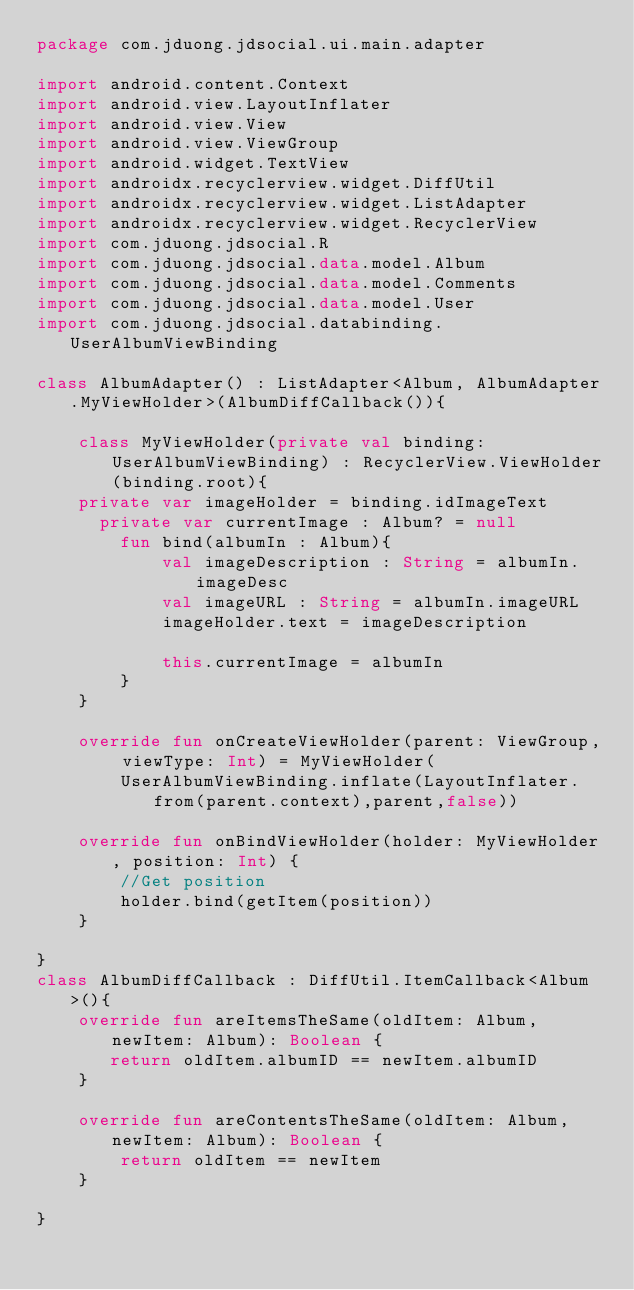<code> <loc_0><loc_0><loc_500><loc_500><_Kotlin_>package com.jduong.jdsocial.ui.main.adapter

import android.content.Context
import android.view.LayoutInflater
import android.view.View
import android.view.ViewGroup
import android.widget.TextView
import androidx.recyclerview.widget.DiffUtil
import androidx.recyclerview.widget.ListAdapter
import androidx.recyclerview.widget.RecyclerView
import com.jduong.jdsocial.R
import com.jduong.jdsocial.data.model.Album
import com.jduong.jdsocial.data.model.Comments
import com.jduong.jdsocial.data.model.User
import com.jduong.jdsocial.databinding.UserAlbumViewBinding

class AlbumAdapter() : ListAdapter<Album, AlbumAdapter.MyViewHolder>(AlbumDiffCallback()){

    class MyViewHolder(private val binding: UserAlbumViewBinding) : RecyclerView.ViewHolder(binding.root){
    private var imageHolder = binding.idImageText
      private var currentImage : Album? = null
        fun bind(albumIn : Album){
            val imageDescription : String = albumIn.imageDesc
            val imageURL : String = albumIn.imageURL
            imageHolder.text = imageDescription

            this.currentImage = albumIn
        }
    }

    override fun onCreateViewHolder(parent: ViewGroup, viewType: Int) = MyViewHolder(
        UserAlbumViewBinding.inflate(LayoutInflater.from(parent.context),parent,false))

    override fun onBindViewHolder(holder: MyViewHolder, position: Int) {
        //Get position
        holder.bind(getItem(position))
    }

}
class AlbumDiffCallback : DiffUtil.ItemCallback<Album>(){
    override fun areItemsTheSame(oldItem: Album, newItem: Album): Boolean {
       return oldItem.albumID == newItem.albumID
    }

    override fun areContentsTheSame(oldItem: Album, newItem: Album): Boolean {
        return oldItem == newItem
    }

}</code> 